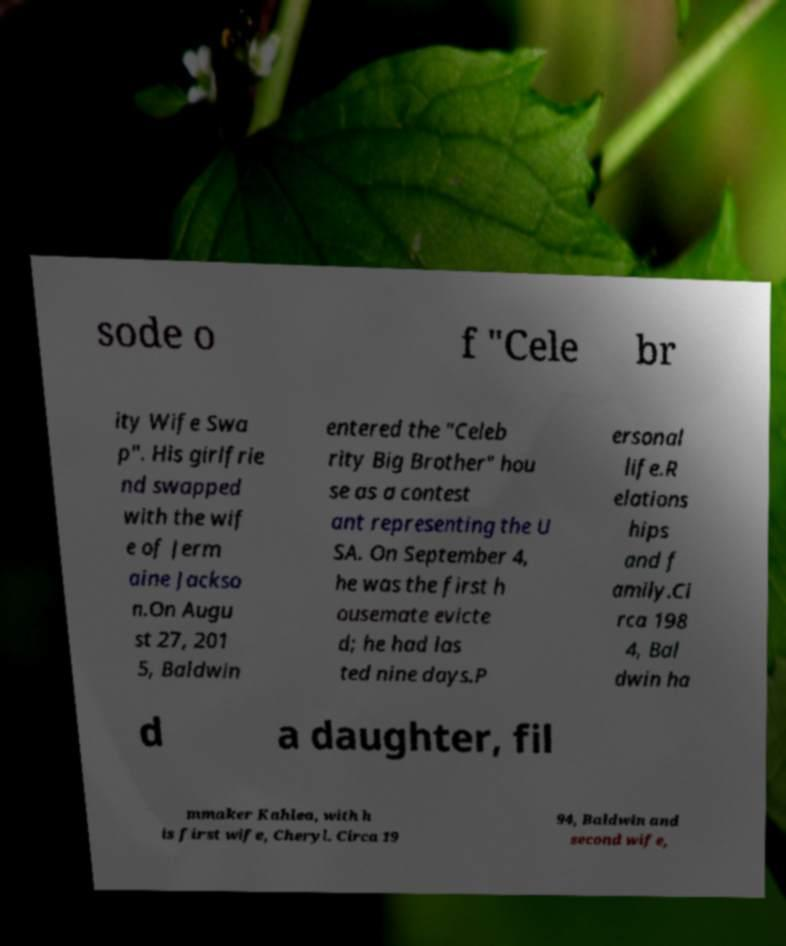There's text embedded in this image that I need extracted. Can you transcribe it verbatim? sode o f "Cele br ity Wife Swa p". His girlfrie nd swapped with the wif e of Jerm aine Jackso n.On Augu st 27, 201 5, Baldwin entered the "Celeb rity Big Brother" hou se as a contest ant representing the U SA. On September 4, he was the first h ousemate evicte d; he had las ted nine days.P ersonal life.R elations hips and f amily.Ci rca 198 4, Bal dwin ha d a daughter, fil mmaker Kahlea, with h is first wife, Cheryl. Circa 19 94, Baldwin and second wife, 